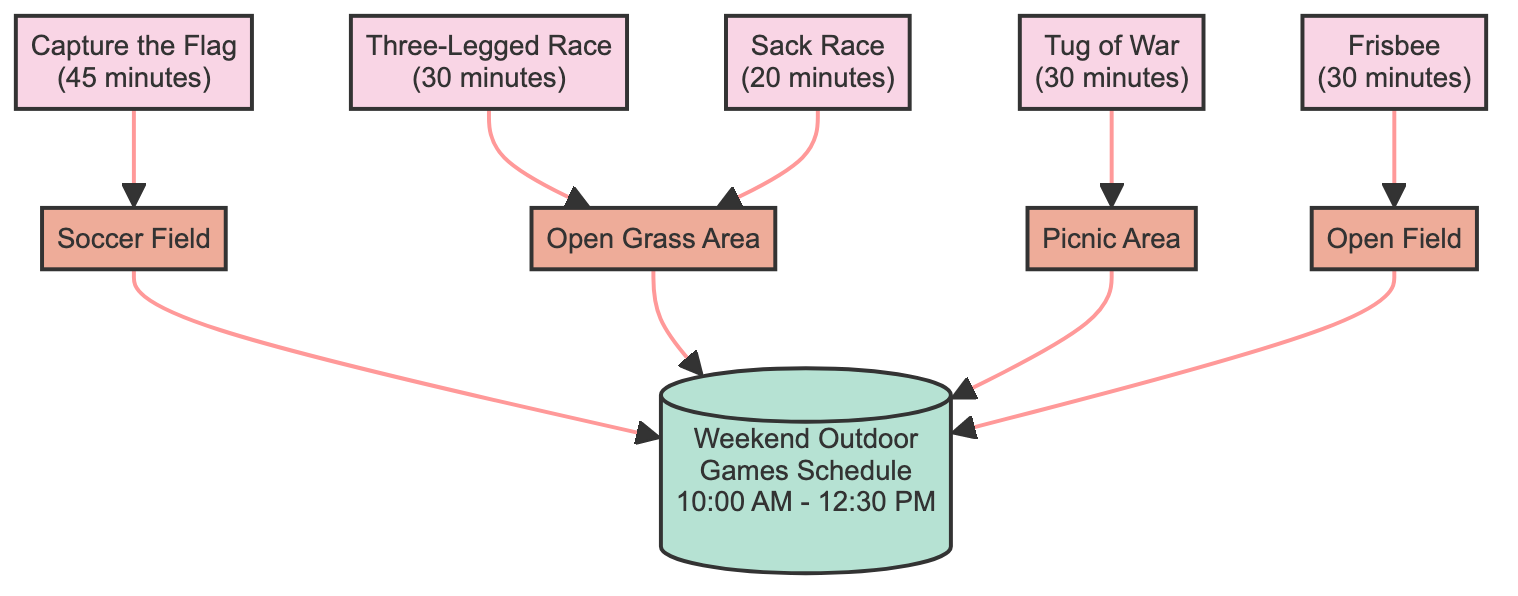What is the first game listed in the schedule? The first game in the schedule, as represented at the top of the flow chart under the "Games" section, is "Capture the Flag."
Answer: Capture the Flag How long does the Sack Race last? The duration of the Sack Race can be found next to its name in the diagram, which states that it lasts for "20 minutes."
Answer: 20 minutes What location is designated for the Tug of War? The Tug of War is connected to its location node in the diagram, which specifies that the location is the "Picnic Area."
Answer: Picnic Area How many outdoor games are included in the schedule? To find the total number of games, you can count the individual game nodes listed in the diagram, which shows five games total.
Answer: 5 Which location has the most games scheduled? By analyzing the game nodes connected to their respective location nodes, we see that the "Open Grass Area" has both the "Three-Legged Race" and "Sack Race," totaling two games. All other locations have one game each.
Answer: Open Grass Area What is the end time of the schedule? The end time of the schedule is displayed prominently in the main schedule node, and it states "12:30 PM."
Answer: 12:30 PM Which game has the longest duration? Looking at the duration next to each game node, "Capture the Flag" is noted to last "45 minutes," which is longer than any other game in the schedule.
Answer: Capture the Flag How does the Capture the Flag relate to its location? In the flow chart, there is a direct connection (arrow) from the Capture the Flag node to the "Soccer Field" node, indicating that this game is assigned to that location.
Answer: Soccer Field Which outdoor game is listed last in the diagram? The last game in the list of games displayed in the diagram is "Frisbee," as it comes after all the other games in the flow.
Answer: Frisbee 